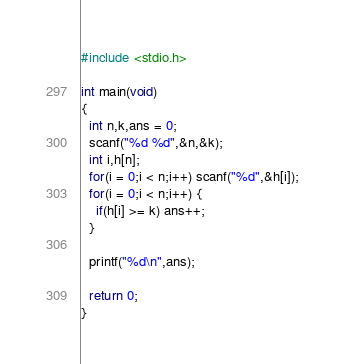<code> <loc_0><loc_0><loc_500><loc_500><_C_>#include <stdio.h>

int main(void)
{
  int n,k,ans = 0;
  scanf("%d %d",&n,&k);
  int i,h[n];
  for(i = 0;i < n;i++) scanf("%d",&h[i]);
  for(i = 0;i < n;i++) {
    if(h[i] >= k) ans++;
  }
    
  printf("%d\n",ans);
  
  return 0;
}
</code> 